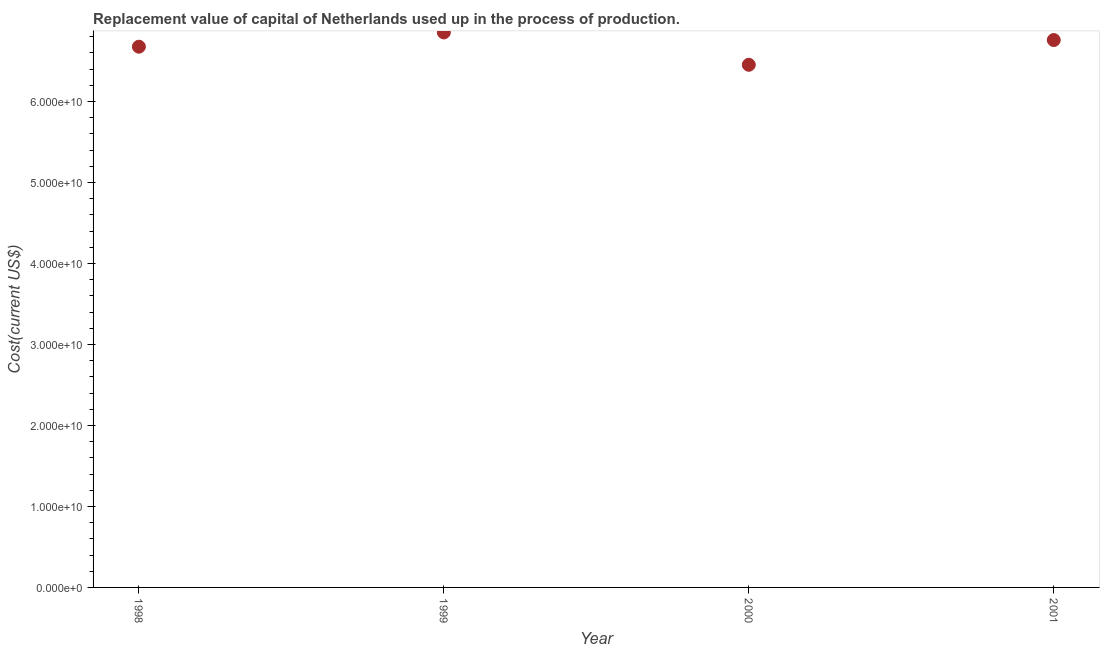What is the consumption of fixed capital in 1999?
Provide a short and direct response. 6.85e+1. Across all years, what is the maximum consumption of fixed capital?
Keep it short and to the point. 6.85e+1. Across all years, what is the minimum consumption of fixed capital?
Give a very brief answer. 6.45e+1. What is the sum of the consumption of fixed capital?
Your response must be concise. 2.67e+11. What is the difference between the consumption of fixed capital in 1998 and 2000?
Offer a very short reply. 2.23e+09. What is the average consumption of fixed capital per year?
Provide a short and direct response. 6.68e+1. What is the median consumption of fixed capital?
Ensure brevity in your answer.  6.72e+1. What is the ratio of the consumption of fixed capital in 2000 to that in 2001?
Your answer should be compact. 0.95. Is the consumption of fixed capital in 1998 less than that in 2001?
Provide a short and direct response. Yes. What is the difference between the highest and the second highest consumption of fixed capital?
Provide a succinct answer. 9.37e+08. What is the difference between the highest and the lowest consumption of fixed capital?
Offer a very short reply. 3.99e+09. What is the title of the graph?
Your response must be concise. Replacement value of capital of Netherlands used up in the process of production. What is the label or title of the X-axis?
Your answer should be very brief. Year. What is the label or title of the Y-axis?
Offer a terse response. Cost(current US$). What is the Cost(current US$) in 1998?
Make the answer very short. 6.68e+1. What is the Cost(current US$) in 1999?
Your response must be concise. 6.85e+1. What is the Cost(current US$) in 2000?
Provide a short and direct response. 6.45e+1. What is the Cost(current US$) in 2001?
Give a very brief answer. 6.76e+1. What is the difference between the Cost(current US$) in 1998 and 1999?
Provide a succinct answer. -1.76e+09. What is the difference between the Cost(current US$) in 1998 and 2000?
Your answer should be compact. 2.23e+09. What is the difference between the Cost(current US$) in 1998 and 2001?
Give a very brief answer. -8.23e+08. What is the difference between the Cost(current US$) in 1999 and 2000?
Offer a very short reply. 3.99e+09. What is the difference between the Cost(current US$) in 1999 and 2001?
Your response must be concise. 9.37e+08. What is the difference between the Cost(current US$) in 2000 and 2001?
Offer a very short reply. -3.06e+09. What is the ratio of the Cost(current US$) in 1998 to that in 2000?
Make the answer very short. 1.03. What is the ratio of the Cost(current US$) in 1998 to that in 2001?
Give a very brief answer. 0.99. What is the ratio of the Cost(current US$) in 1999 to that in 2000?
Offer a very short reply. 1.06. What is the ratio of the Cost(current US$) in 1999 to that in 2001?
Provide a short and direct response. 1.01. What is the ratio of the Cost(current US$) in 2000 to that in 2001?
Ensure brevity in your answer.  0.95. 